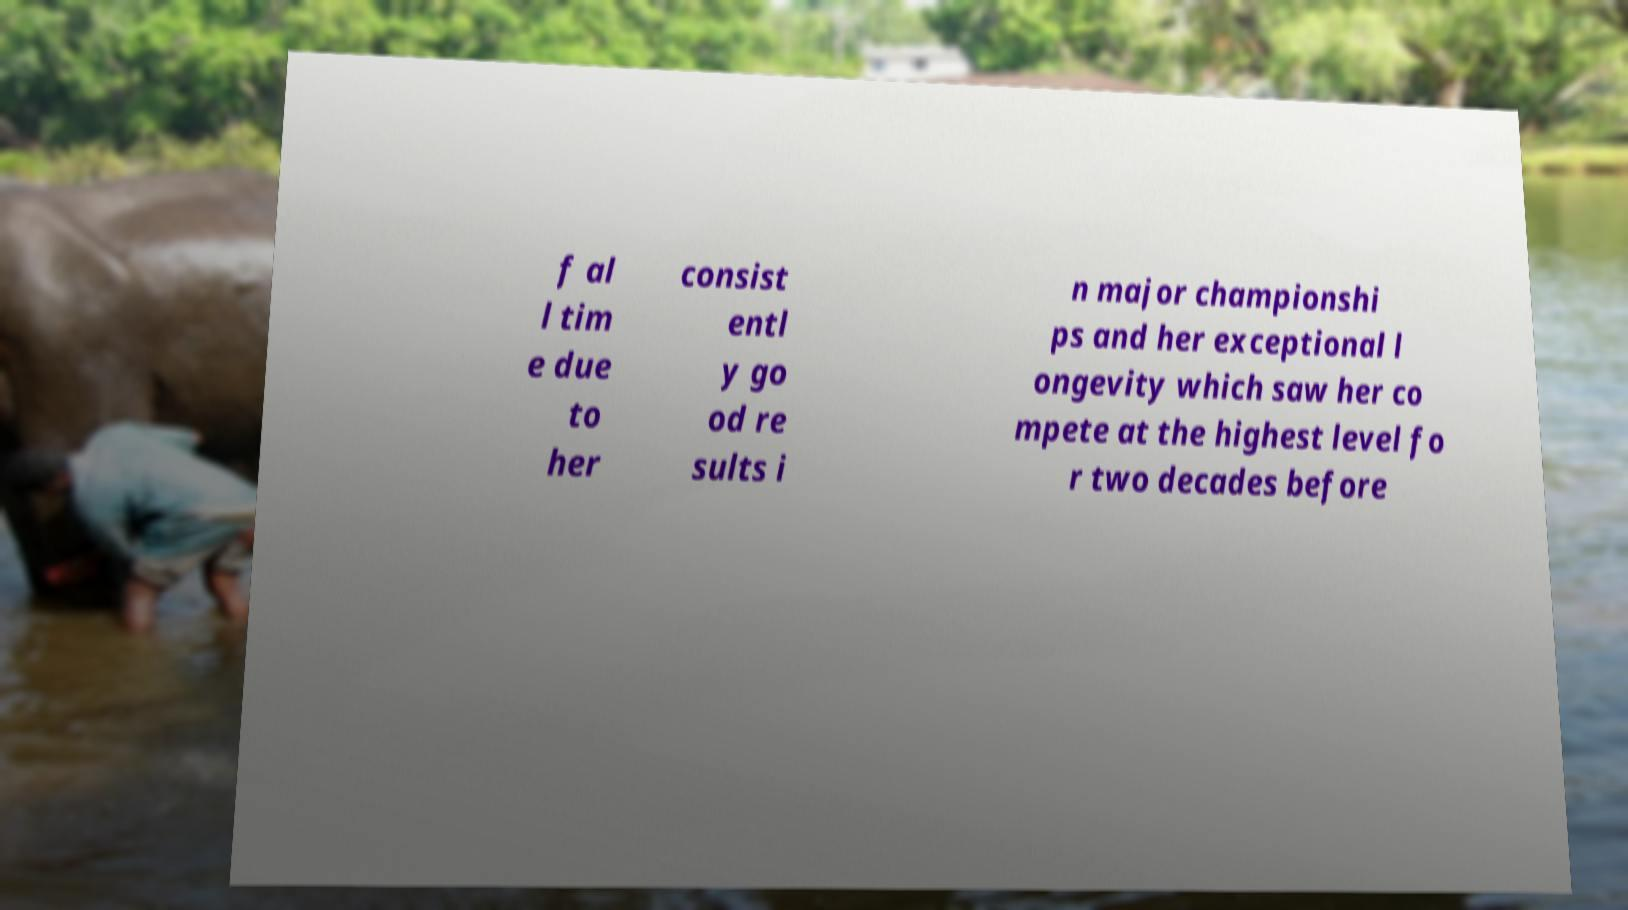What messages or text are displayed in this image? I need them in a readable, typed format. f al l tim e due to her consist entl y go od re sults i n major championshi ps and her exceptional l ongevity which saw her co mpete at the highest level fo r two decades before 